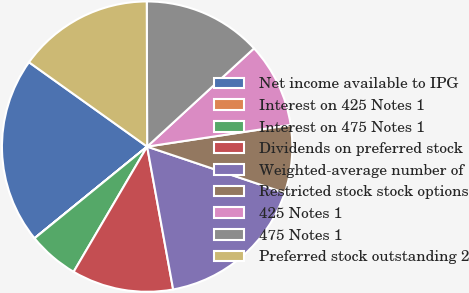Convert chart. <chart><loc_0><loc_0><loc_500><loc_500><pie_chart><fcel>Net income available to IPG<fcel>Interest on 425 Notes 1<fcel>Interest on 475 Notes 1<fcel>Dividends on preferred stock<fcel>Weighted-average number of<fcel>Restricted stock stock options<fcel>425 Notes 1<fcel>475 Notes 1<fcel>Preferred stock outstanding 2<nl><fcel>20.74%<fcel>0.01%<fcel>5.67%<fcel>11.32%<fcel>16.97%<fcel>7.55%<fcel>9.44%<fcel>13.21%<fcel>15.09%<nl></chart> 